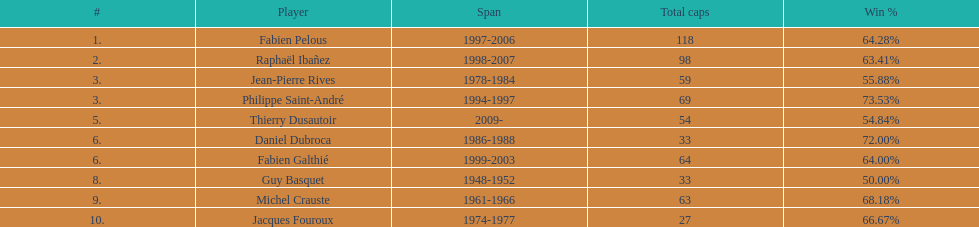What is the number of captains who participated in 11 capped games? 5. 